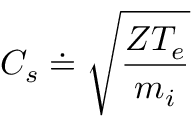<formula> <loc_0><loc_0><loc_500><loc_500>C _ { s } \doteq \sqrt { \frac { Z T _ { e } } { m _ { i } } }</formula> 